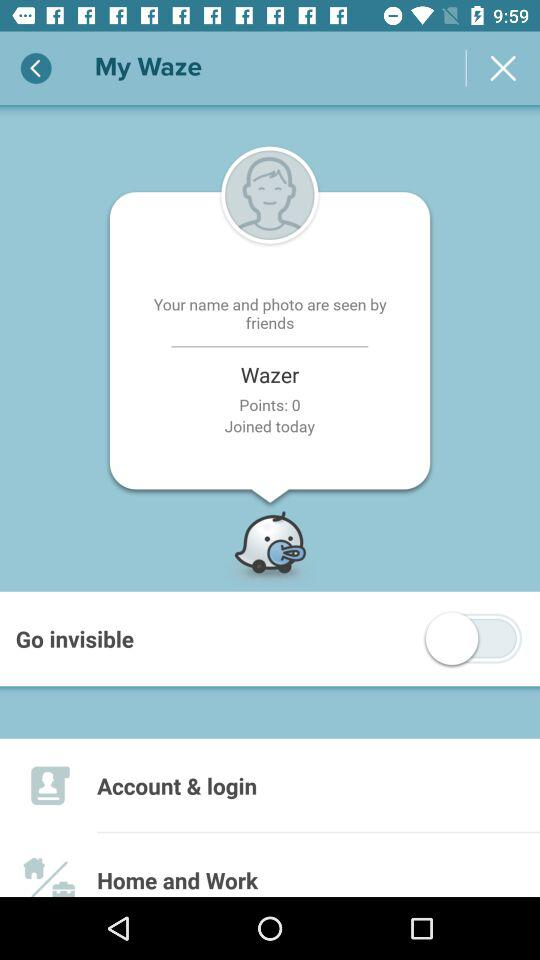How many points does the user have?
Answer the question using a single word or phrase. 0 